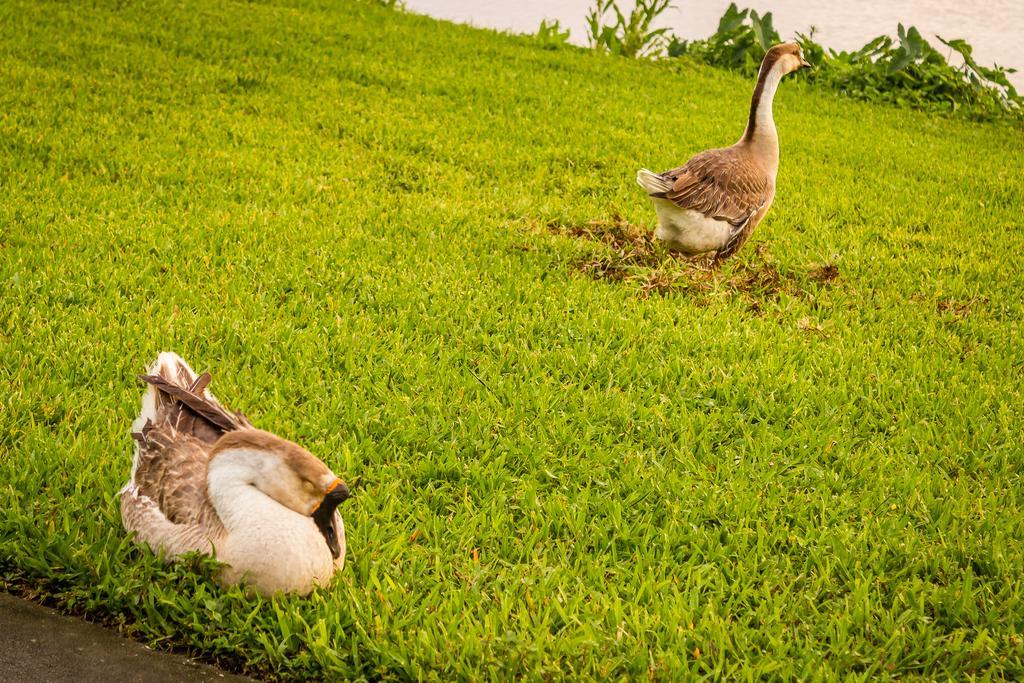How would you summarize this image in a sentence or two? In the picture we can see a grass surface on it, we can see two ducks, one is standing and one is sitting near the part of the path and in the background, we can see some plants and behind it we can see a part of the water. 